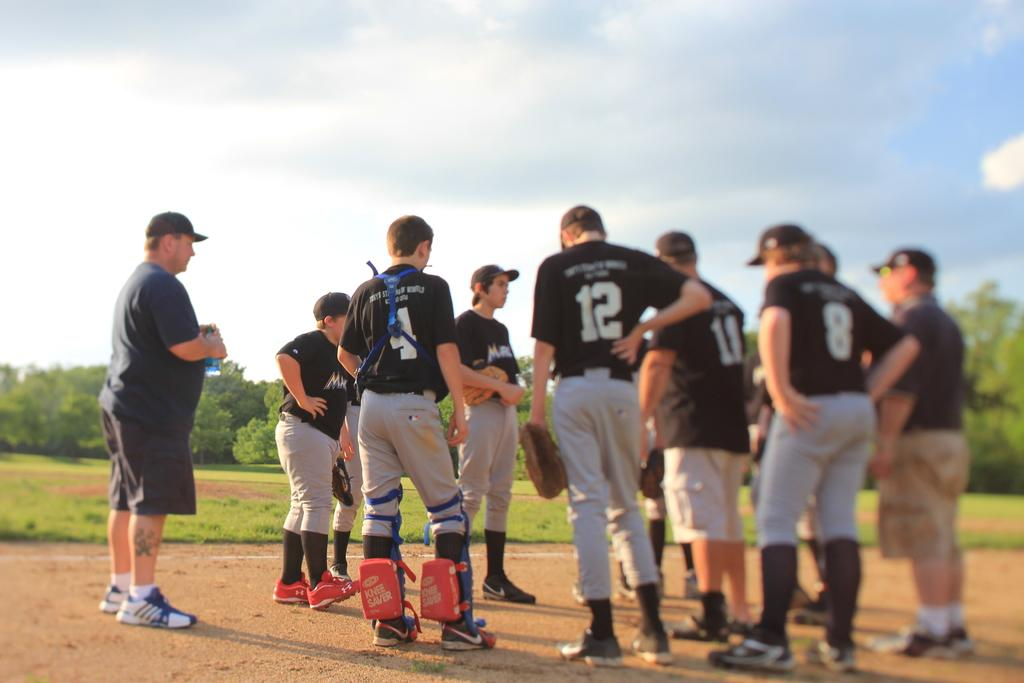Provide a one-sentence caption for the provided image. The baseball teams catcher is wearing number 4. 